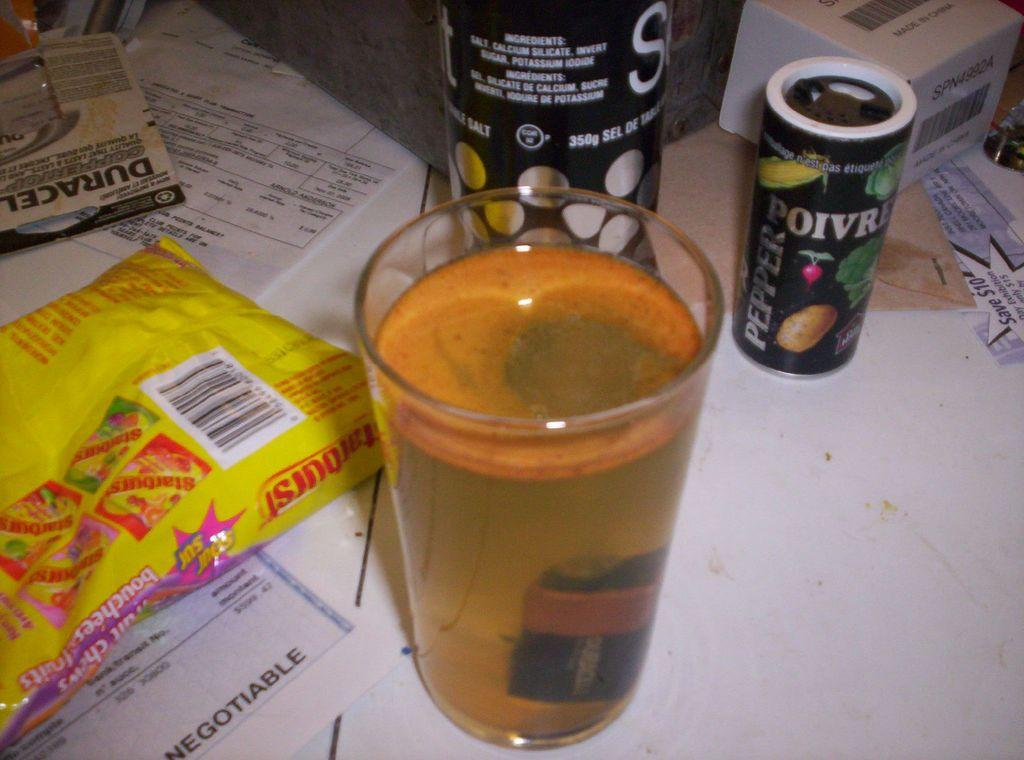Provide a one-sentence caption for the provided image. A bag of starburst lay on top of  check on a table full of other things. 